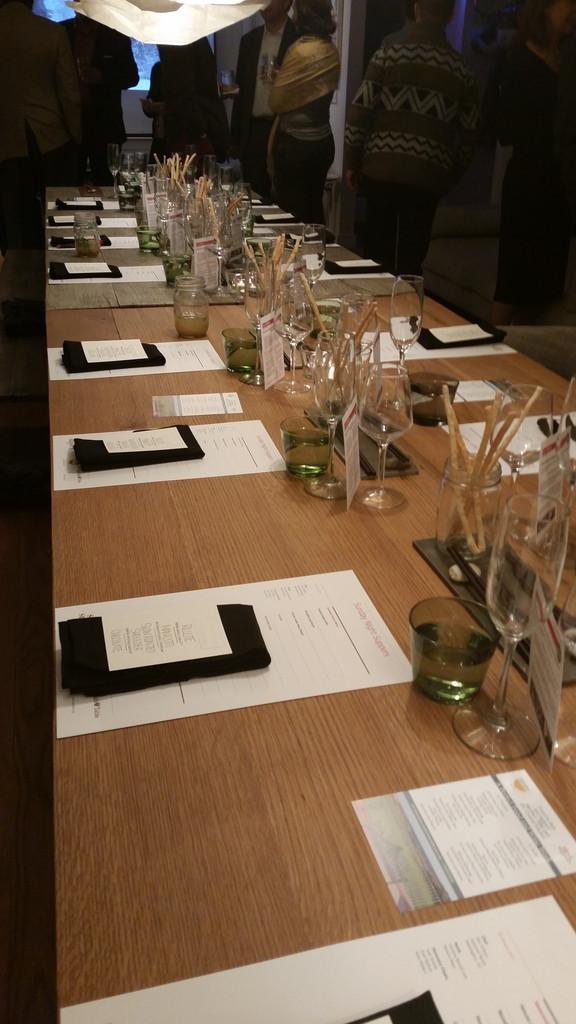Can you describe this image briefly? In this image there are group of people standing in the background and in the front there is a table with a glasses on the table and paper which is kept on the table. 